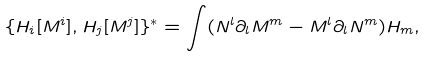Convert formula to latex. <formula><loc_0><loc_0><loc_500><loc_500>\{ H _ { i } [ M ^ { i } ] , H _ { j } [ M ^ { j } ] \} ^ { * } = \int ( N ^ { l } \partial _ { l } M ^ { m } - M ^ { l } \partial _ { l } N ^ { m } ) H _ { m } ,</formula> 